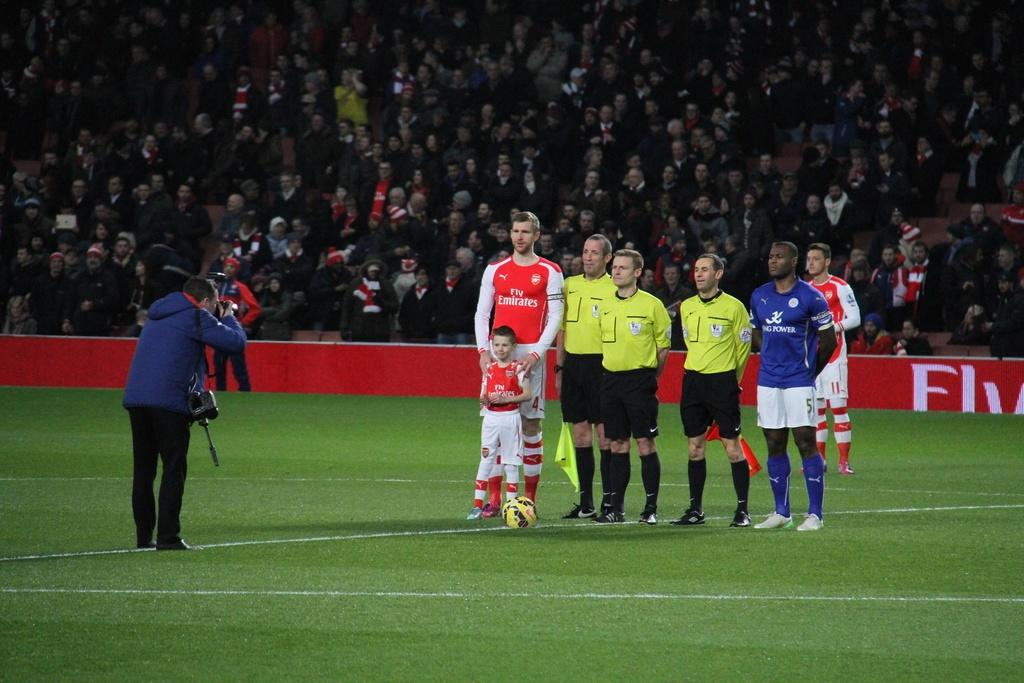<image>
Present a compact description of the photo's key features. some sports players getting their picture taken on a game field, one man has Fly Emirates on his shirt and the other one has King Power. 